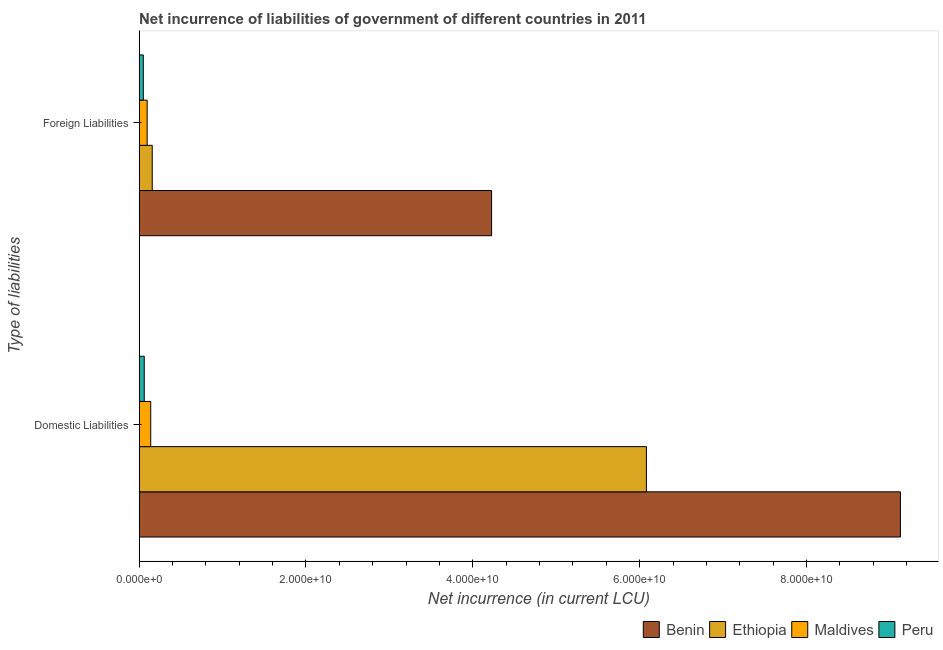How many bars are there on the 1st tick from the top?
Your response must be concise. 4. How many bars are there on the 1st tick from the bottom?
Keep it short and to the point. 4. What is the label of the 1st group of bars from the top?
Provide a short and direct response. Foreign Liabilities. What is the net incurrence of domestic liabilities in Peru?
Make the answer very short. 6.16e+08. Across all countries, what is the maximum net incurrence of domestic liabilities?
Ensure brevity in your answer.  9.13e+1. Across all countries, what is the minimum net incurrence of domestic liabilities?
Your answer should be very brief. 6.16e+08. In which country was the net incurrence of domestic liabilities maximum?
Ensure brevity in your answer.  Benin. In which country was the net incurrence of foreign liabilities minimum?
Offer a terse response. Peru. What is the total net incurrence of domestic liabilities in the graph?
Your answer should be very brief. 1.54e+11. What is the difference between the net incurrence of domestic liabilities in Maldives and that in Peru?
Make the answer very short. 7.76e+08. What is the difference between the net incurrence of domestic liabilities in Maldives and the net incurrence of foreign liabilities in Peru?
Ensure brevity in your answer.  8.89e+08. What is the average net incurrence of domestic liabilities per country?
Offer a very short reply. 3.85e+1. What is the difference between the net incurrence of domestic liabilities and net incurrence of foreign liabilities in Peru?
Your answer should be very brief. 1.13e+08. In how many countries, is the net incurrence of foreign liabilities greater than 76000000000 LCU?
Your answer should be very brief. 0. What is the ratio of the net incurrence of foreign liabilities in Maldives to that in Benin?
Make the answer very short. 0.02. In how many countries, is the net incurrence of domestic liabilities greater than the average net incurrence of domestic liabilities taken over all countries?
Offer a very short reply. 2. What does the 2nd bar from the top in Foreign Liabilities represents?
Your answer should be very brief. Maldives. How many countries are there in the graph?
Make the answer very short. 4. What is the difference between two consecutive major ticks on the X-axis?
Provide a short and direct response. 2.00e+1. Does the graph contain grids?
Offer a terse response. No. Where does the legend appear in the graph?
Provide a succinct answer. Bottom right. How many legend labels are there?
Provide a short and direct response. 4. What is the title of the graph?
Make the answer very short. Net incurrence of liabilities of government of different countries in 2011. What is the label or title of the X-axis?
Offer a terse response. Net incurrence (in current LCU). What is the label or title of the Y-axis?
Make the answer very short. Type of liabilities. What is the Net incurrence (in current LCU) in Benin in Domestic Liabilities?
Your response must be concise. 9.13e+1. What is the Net incurrence (in current LCU) of Ethiopia in Domestic Liabilities?
Keep it short and to the point. 6.08e+1. What is the Net incurrence (in current LCU) in Maldives in Domestic Liabilities?
Ensure brevity in your answer.  1.39e+09. What is the Net incurrence (in current LCU) in Peru in Domestic Liabilities?
Make the answer very short. 6.16e+08. What is the Net incurrence (in current LCU) in Benin in Foreign Liabilities?
Your answer should be compact. 4.23e+1. What is the Net incurrence (in current LCU) of Ethiopia in Foreign Liabilities?
Provide a short and direct response. 1.57e+09. What is the Net incurrence (in current LCU) of Maldives in Foreign Liabilities?
Your answer should be very brief. 9.68e+08. What is the Net incurrence (in current LCU) of Peru in Foreign Liabilities?
Your response must be concise. 5.03e+08. Across all Type of liabilities, what is the maximum Net incurrence (in current LCU) of Benin?
Give a very brief answer. 9.13e+1. Across all Type of liabilities, what is the maximum Net incurrence (in current LCU) in Ethiopia?
Your answer should be compact. 6.08e+1. Across all Type of liabilities, what is the maximum Net incurrence (in current LCU) of Maldives?
Offer a very short reply. 1.39e+09. Across all Type of liabilities, what is the maximum Net incurrence (in current LCU) of Peru?
Ensure brevity in your answer.  6.16e+08. Across all Type of liabilities, what is the minimum Net incurrence (in current LCU) of Benin?
Provide a succinct answer. 4.23e+1. Across all Type of liabilities, what is the minimum Net incurrence (in current LCU) in Ethiopia?
Provide a succinct answer. 1.57e+09. Across all Type of liabilities, what is the minimum Net incurrence (in current LCU) of Maldives?
Your answer should be compact. 9.68e+08. Across all Type of liabilities, what is the minimum Net incurrence (in current LCU) in Peru?
Make the answer very short. 5.03e+08. What is the total Net incurrence (in current LCU) of Benin in the graph?
Offer a very short reply. 1.34e+11. What is the total Net incurrence (in current LCU) in Ethiopia in the graph?
Provide a short and direct response. 6.24e+1. What is the total Net incurrence (in current LCU) of Maldives in the graph?
Ensure brevity in your answer.  2.36e+09. What is the total Net incurrence (in current LCU) of Peru in the graph?
Keep it short and to the point. 1.12e+09. What is the difference between the Net incurrence (in current LCU) of Benin in Domestic Liabilities and that in Foreign Liabilities?
Your response must be concise. 4.90e+1. What is the difference between the Net incurrence (in current LCU) of Ethiopia in Domestic Liabilities and that in Foreign Liabilities?
Your answer should be very brief. 5.92e+1. What is the difference between the Net incurrence (in current LCU) in Maldives in Domestic Liabilities and that in Foreign Liabilities?
Offer a very short reply. 4.24e+08. What is the difference between the Net incurrence (in current LCU) of Peru in Domestic Liabilities and that in Foreign Liabilities?
Your response must be concise. 1.13e+08. What is the difference between the Net incurrence (in current LCU) of Benin in Domestic Liabilities and the Net incurrence (in current LCU) of Ethiopia in Foreign Liabilities?
Offer a very short reply. 8.97e+1. What is the difference between the Net incurrence (in current LCU) of Benin in Domestic Liabilities and the Net incurrence (in current LCU) of Maldives in Foreign Liabilities?
Your answer should be very brief. 9.03e+1. What is the difference between the Net incurrence (in current LCU) in Benin in Domestic Liabilities and the Net incurrence (in current LCU) in Peru in Foreign Liabilities?
Your answer should be very brief. 9.08e+1. What is the difference between the Net incurrence (in current LCU) in Ethiopia in Domestic Liabilities and the Net incurrence (in current LCU) in Maldives in Foreign Liabilities?
Provide a short and direct response. 5.98e+1. What is the difference between the Net incurrence (in current LCU) of Ethiopia in Domestic Liabilities and the Net incurrence (in current LCU) of Peru in Foreign Liabilities?
Provide a short and direct response. 6.03e+1. What is the difference between the Net incurrence (in current LCU) in Maldives in Domestic Liabilities and the Net incurrence (in current LCU) in Peru in Foreign Liabilities?
Your answer should be compact. 8.89e+08. What is the average Net incurrence (in current LCU) in Benin per Type of liabilities?
Give a very brief answer. 6.68e+1. What is the average Net incurrence (in current LCU) in Ethiopia per Type of liabilities?
Make the answer very short. 3.12e+1. What is the average Net incurrence (in current LCU) of Maldives per Type of liabilities?
Keep it short and to the point. 1.18e+09. What is the average Net incurrence (in current LCU) of Peru per Type of liabilities?
Your answer should be very brief. 5.60e+08. What is the difference between the Net incurrence (in current LCU) of Benin and Net incurrence (in current LCU) of Ethiopia in Domestic Liabilities?
Your response must be concise. 3.04e+1. What is the difference between the Net incurrence (in current LCU) of Benin and Net incurrence (in current LCU) of Maldives in Domestic Liabilities?
Your answer should be very brief. 8.99e+1. What is the difference between the Net incurrence (in current LCU) of Benin and Net incurrence (in current LCU) of Peru in Domestic Liabilities?
Keep it short and to the point. 9.06e+1. What is the difference between the Net incurrence (in current LCU) in Ethiopia and Net incurrence (in current LCU) in Maldives in Domestic Liabilities?
Give a very brief answer. 5.94e+1. What is the difference between the Net incurrence (in current LCU) of Ethiopia and Net incurrence (in current LCU) of Peru in Domestic Liabilities?
Provide a short and direct response. 6.02e+1. What is the difference between the Net incurrence (in current LCU) of Maldives and Net incurrence (in current LCU) of Peru in Domestic Liabilities?
Provide a succinct answer. 7.76e+08. What is the difference between the Net incurrence (in current LCU) in Benin and Net incurrence (in current LCU) in Ethiopia in Foreign Liabilities?
Provide a short and direct response. 4.07e+1. What is the difference between the Net incurrence (in current LCU) of Benin and Net incurrence (in current LCU) of Maldives in Foreign Liabilities?
Offer a terse response. 4.13e+1. What is the difference between the Net incurrence (in current LCU) of Benin and Net incurrence (in current LCU) of Peru in Foreign Liabilities?
Provide a short and direct response. 4.17e+1. What is the difference between the Net incurrence (in current LCU) in Ethiopia and Net incurrence (in current LCU) in Maldives in Foreign Liabilities?
Provide a short and direct response. 6.07e+08. What is the difference between the Net incurrence (in current LCU) of Ethiopia and Net incurrence (in current LCU) of Peru in Foreign Liabilities?
Your response must be concise. 1.07e+09. What is the difference between the Net incurrence (in current LCU) in Maldives and Net incurrence (in current LCU) in Peru in Foreign Liabilities?
Your answer should be compact. 4.65e+08. What is the ratio of the Net incurrence (in current LCU) in Benin in Domestic Liabilities to that in Foreign Liabilities?
Provide a short and direct response. 2.16. What is the ratio of the Net incurrence (in current LCU) in Ethiopia in Domestic Liabilities to that in Foreign Liabilities?
Your response must be concise. 38.61. What is the ratio of the Net incurrence (in current LCU) of Maldives in Domestic Liabilities to that in Foreign Liabilities?
Your answer should be very brief. 1.44. What is the ratio of the Net incurrence (in current LCU) of Peru in Domestic Liabilities to that in Foreign Liabilities?
Your answer should be very brief. 1.23. What is the difference between the highest and the second highest Net incurrence (in current LCU) in Benin?
Provide a succinct answer. 4.90e+1. What is the difference between the highest and the second highest Net incurrence (in current LCU) in Ethiopia?
Offer a terse response. 5.92e+1. What is the difference between the highest and the second highest Net incurrence (in current LCU) in Maldives?
Provide a succinct answer. 4.24e+08. What is the difference between the highest and the second highest Net incurrence (in current LCU) of Peru?
Your response must be concise. 1.13e+08. What is the difference between the highest and the lowest Net incurrence (in current LCU) of Benin?
Provide a short and direct response. 4.90e+1. What is the difference between the highest and the lowest Net incurrence (in current LCU) in Ethiopia?
Make the answer very short. 5.92e+1. What is the difference between the highest and the lowest Net incurrence (in current LCU) in Maldives?
Offer a very short reply. 4.24e+08. What is the difference between the highest and the lowest Net incurrence (in current LCU) of Peru?
Provide a short and direct response. 1.13e+08. 